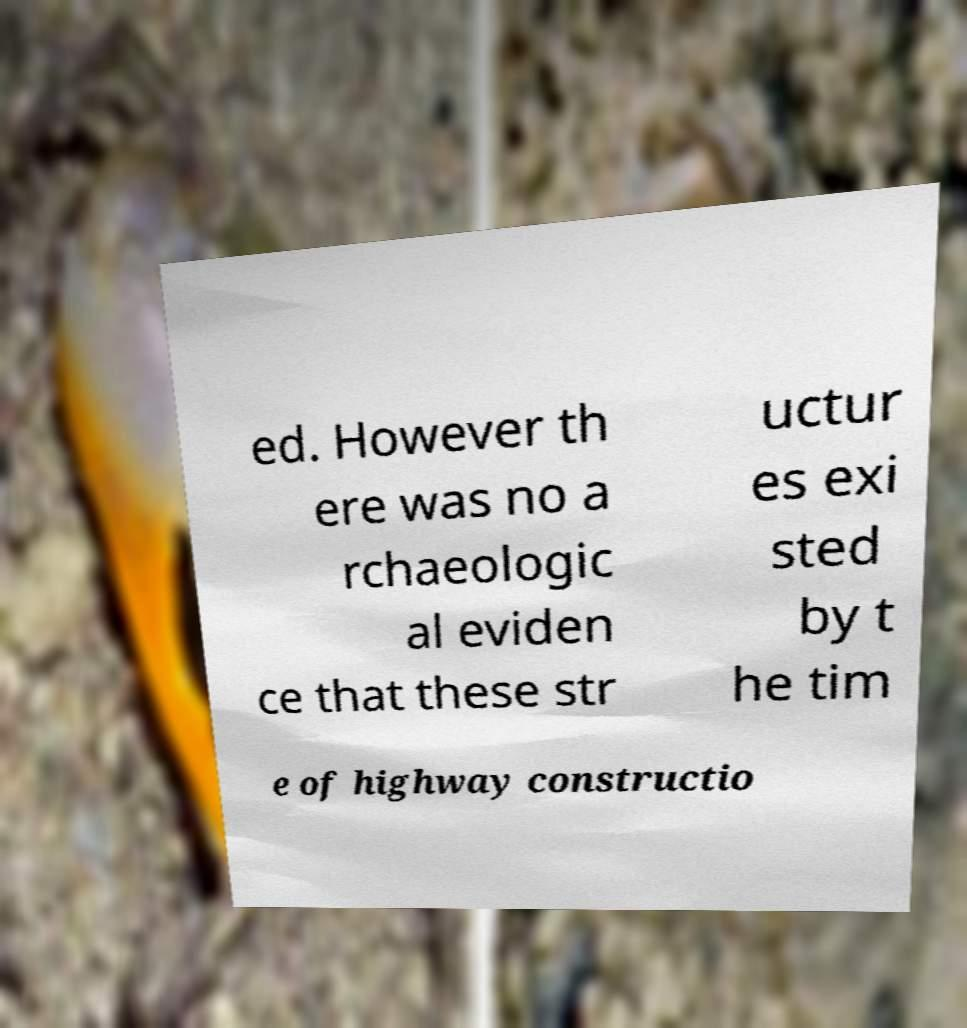Could you extract and type out the text from this image? ed. However th ere was no a rchaeologic al eviden ce that these str uctur es exi sted by t he tim e of highway constructio 